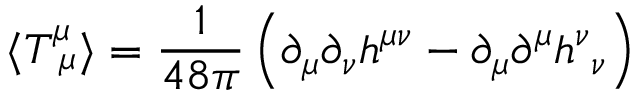<formula> <loc_0><loc_0><loc_500><loc_500>\langle T _ { \ \mu } ^ { \mu } \rangle = \frac { 1 } { 4 8 \pi } \left ( \partial _ { \mu } \partial _ { \nu } h ^ { \mu \nu } - \partial _ { \mu } \partial ^ { \mu } h _ { \ \nu } ^ { \nu } \right )</formula> 